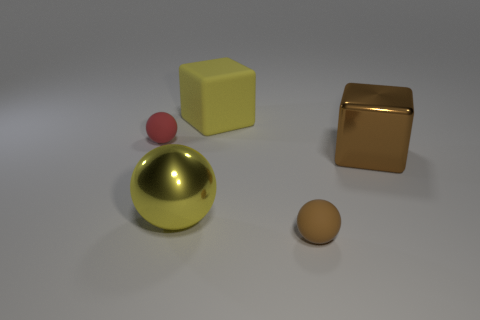Subtract all large metal spheres. How many spheres are left? 2 Add 5 tiny blue blocks. How many objects exist? 10 Subtract all spheres. How many objects are left? 2 Add 5 big brown metal cubes. How many big brown metal cubes are left? 6 Add 3 cyan rubber cylinders. How many cyan rubber cylinders exist? 3 Subtract 0 blue cylinders. How many objects are left? 5 Subtract all red matte things. Subtract all yellow things. How many objects are left? 2 